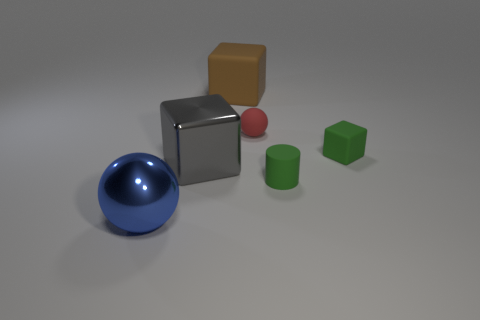Add 3 tiny red matte objects. How many objects exist? 9 Subtract all tiny green rubber cubes. How many cubes are left? 2 Subtract all blue spheres. How many spheres are left? 1 Subtract all cylinders. How many objects are left? 5 Subtract all red cylinders. Subtract all yellow cubes. How many cylinders are left? 1 Subtract all small green blocks. Subtract all balls. How many objects are left? 3 Add 5 tiny spheres. How many tiny spheres are left? 6 Add 3 small cyan cubes. How many small cyan cubes exist? 3 Subtract 0 purple cylinders. How many objects are left? 6 